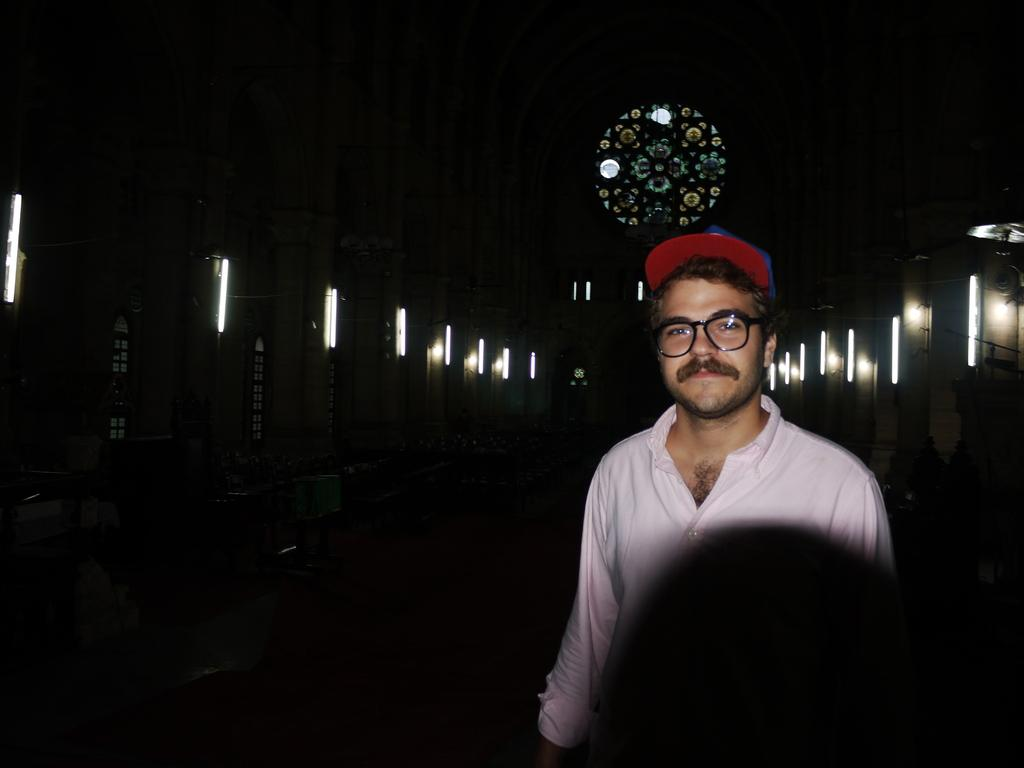Who is present in the image? There is a man in the image. Where is the man located in the image? The man is on the right side of the image. What is the man wearing on his head? The man is wearing a cap. What is the man wearing on his upper body? The man is wearing a shirt. What can be seen in the background of the image? There are lights visible in the background of the image. How would you describe the overall lighting in the image? The background of the image is dark. What type of grass is growing on the man's sister's slip in the image? There is no grass, sister, or slip present in the image. 